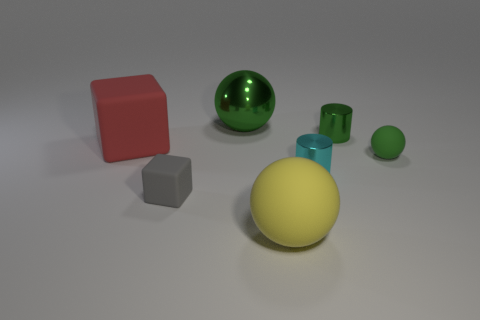Subtract all yellow balls. How many balls are left? 2 Subtract 1 cylinders. How many cylinders are left? 1 Subtract all green cylinders. How many cylinders are left? 1 Subtract all balls. How many objects are left? 4 Subtract 1 gray cubes. How many objects are left? 6 Subtract all purple cylinders. Subtract all yellow balls. How many cylinders are left? 2 Subtract all red spheres. How many gray blocks are left? 1 Subtract all tiny rubber balls. Subtract all yellow things. How many objects are left? 5 Add 6 cubes. How many cubes are left? 8 Add 6 big spheres. How many big spheres exist? 8 